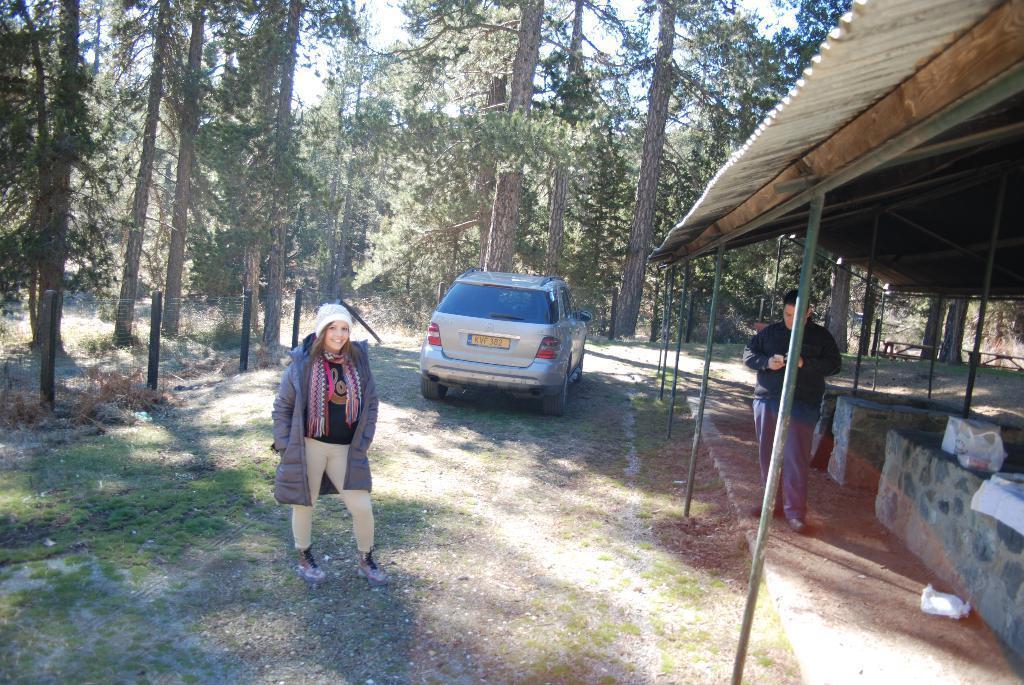Could you give a brief overview of what you see in this image? In this image we can see a lady wearing cap. Also there is another person. And there is a car. On the right side there is a shed with pillars. In the background there are trees. And there is sky. Also there are few items on the right side. 